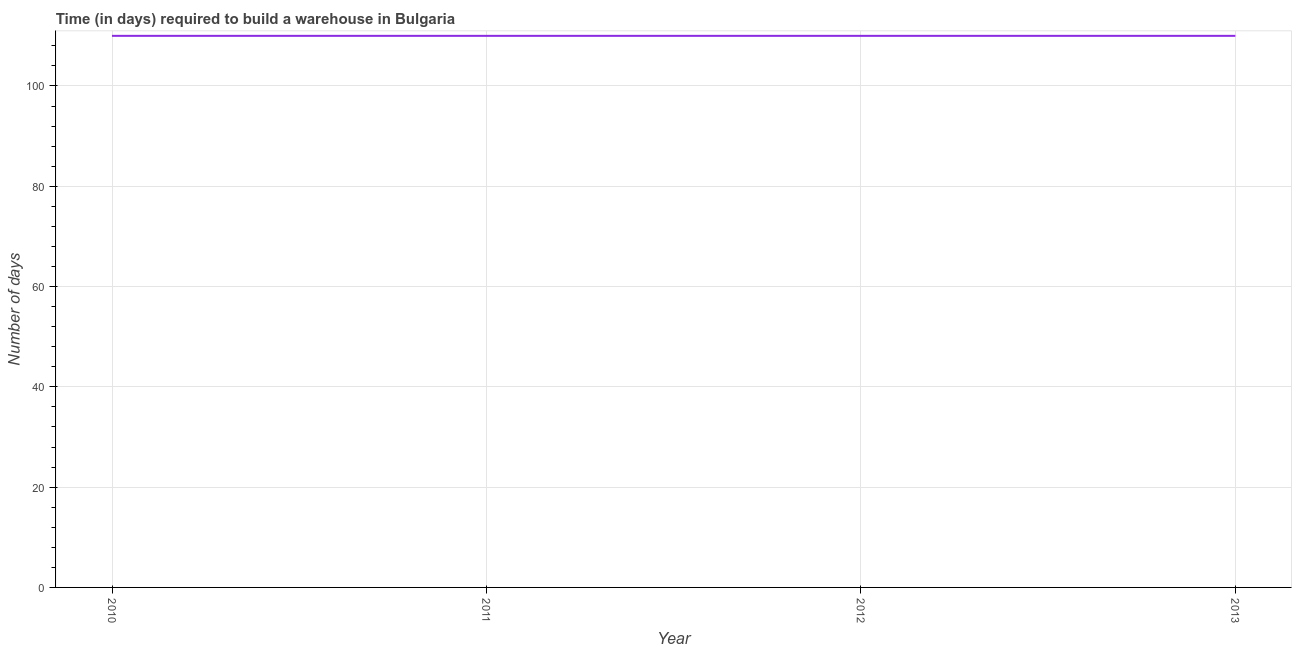What is the time required to build a warehouse in 2013?
Give a very brief answer. 110. Across all years, what is the maximum time required to build a warehouse?
Offer a very short reply. 110. Across all years, what is the minimum time required to build a warehouse?
Your response must be concise. 110. In which year was the time required to build a warehouse maximum?
Your response must be concise. 2010. In which year was the time required to build a warehouse minimum?
Your response must be concise. 2010. What is the sum of the time required to build a warehouse?
Give a very brief answer. 440. What is the average time required to build a warehouse per year?
Keep it short and to the point. 110. What is the median time required to build a warehouse?
Keep it short and to the point. 110. Do a majority of the years between 2010 and 2011 (inclusive) have time required to build a warehouse greater than 100 days?
Provide a short and direct response. Yes. What is the difference between the highest and the second highest time required to build a warehouse?
Keep it short and to the point. 0. What is the difference between the highest and the lowest time required to build a warehouse?
Provide a succinct answer. 0. Does the time required to build a warehouse monotonically increase over the years?
Your answer should be compact. No. How many years are there in the graph?
Offer a terse response. 4. Are the values on the major ticks of Y-axis written in scientific E-notation?
Offer a terse response. No. Does the graph contain any zero values?
Make the answer very short. No. What is the title of the graph?
Keep it short and to the point. Time (in days) required to build a warehouse in Bulgaria. What is the label or title of the X-axis?
Your answer should be very brief. Year. What is the label or title of the Y-axis?
Your answer should be compact. Number of days. What is the Number of days of 2010?
Provide a succinct answer. 110. What is the Number of days in 2011?
Your response must be concise. 110. What is the Number of days of 2012?
Ensure brevity in your answer.  110. What is the Number of days of 2013?
Your answer should be very brief. 110. What is the difference between the Number of days in 2010 and 2011?
Your response must be concise. 0. What is the difference between the Number of days in 2010 and 2013?
Offer a very short reply. 0. What is the ratio of the Number of days in 2011 to that in 2012?
Give a very brief answer. 1. 